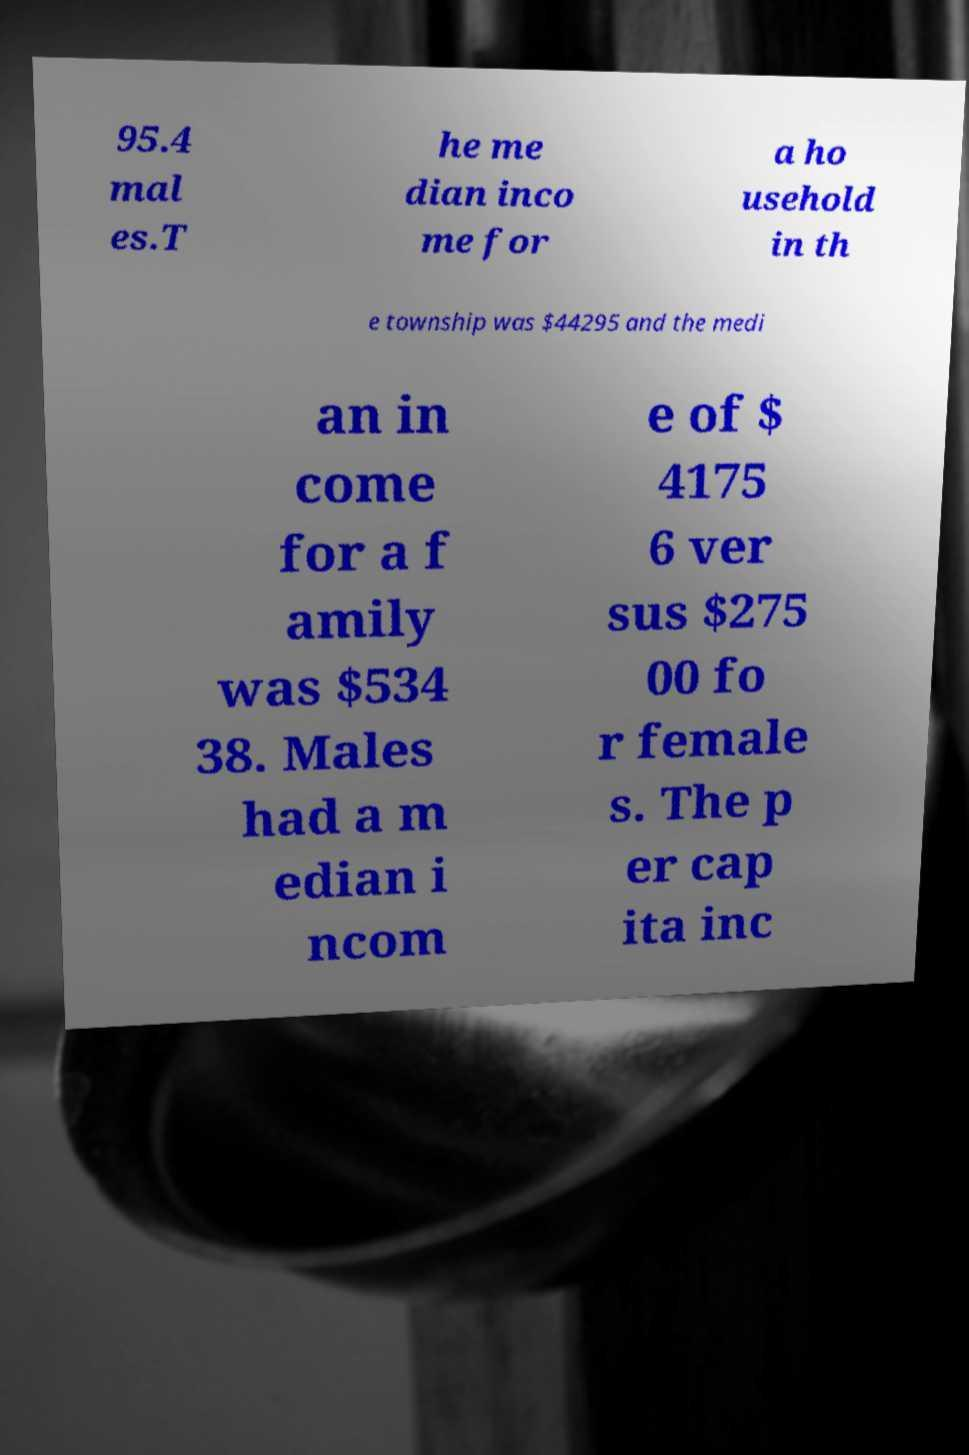What messages or text are displayed in this image? I need them in a readable, typed format. 95.4 mal es.T he me dian inco me for a ho usehold in th e township was $44295 and the medi an in come for a f amily was $534 38. Males had a m edian i ncom e of $ 4175 6 ver sus $275 00 fo r female s. The p er cap ita inc 